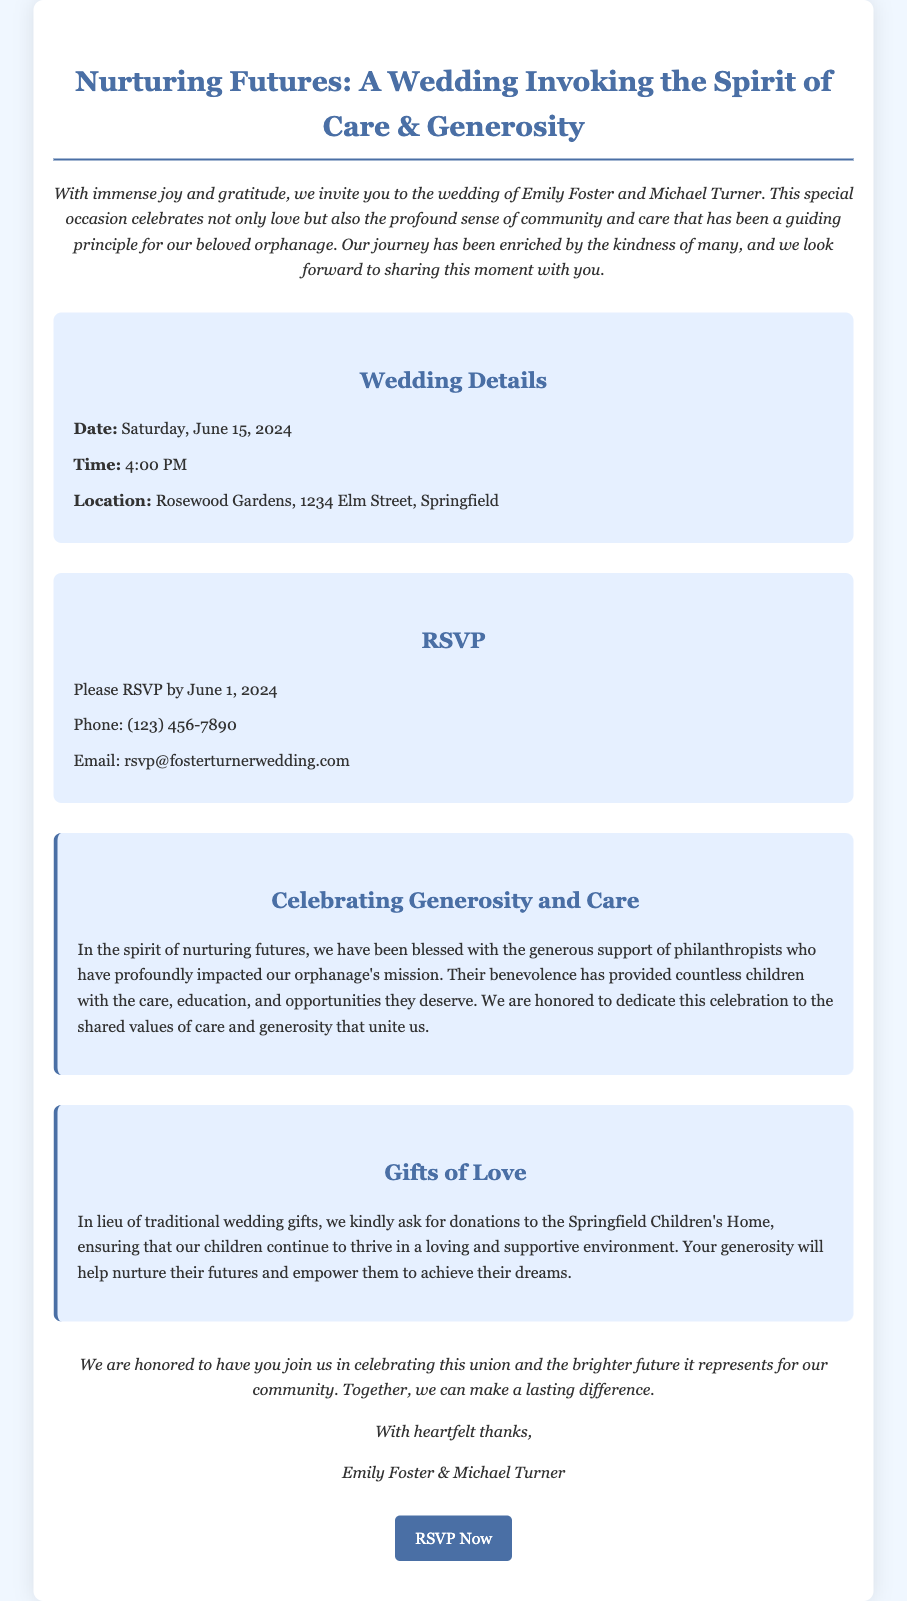what are the names of the couple getting married? The document specifies that the wedding is for Emily Foster and Michael Turner.
Answer: Emily Foster and Michael Turner what is the date of the wedding? The wedding is scheduled for Saturday, June 15, 2024, as mentioned in the details section.
Answer: Saturday, June 15, 2024 where is the wedding taking place? The location for the wedding is provided as Rosewood Gardens, 1234 Elm Street, Springfield.
Answer: Rosewood Gardens, 1234 Elm Street, Springfield what time will the wedding ceremony start? The invitation states that the wedding ceremony will start at 4:00 PM.
Answer: 4:00 PM when is the RSVP deadline? The document mentions that RSVPs should be received by June 1, 2024.
Answer: June 1, 2024 what is the focus of the wedding celebration? The wedding is themed around nurturing futures and the spirit of care and generosity.
Answer: nurturing futures and the spirit of care and generosity what should guests do instead of giving traditional gifts? Guests are asked to make donations to the Springfield Children's Home instead of traditional wedding gifts.
Answer: donations to the Springfield Children's Home who are being honored for their contributions to the orphanage? The document highlights the support of philanthropists who have impacted the orphanage's mission.
Answer: philanthropists what is the message conveyed in the closing remarks? The closing remarks emphasize celebrating the union and making a lasting difference together.
Answer: celebrating the union and making a lasting difference together 